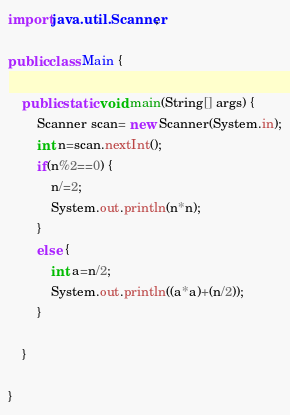<code> <loc_0><loc_0><loc_500><loc_500><_Java_>import java.util.Scanner;

public class Main {

	public static void main(String[] args) {
		Scanner scan= new Scanner(System.in);
		int n=scan.nextInt();
		if(n%2==0) {
			n/=2;
			System.out.println(n*n);
		}
		else {
			int a=n/2;
			System.out.println((a*a)+(n/2));
		}

	}

}
</code> 